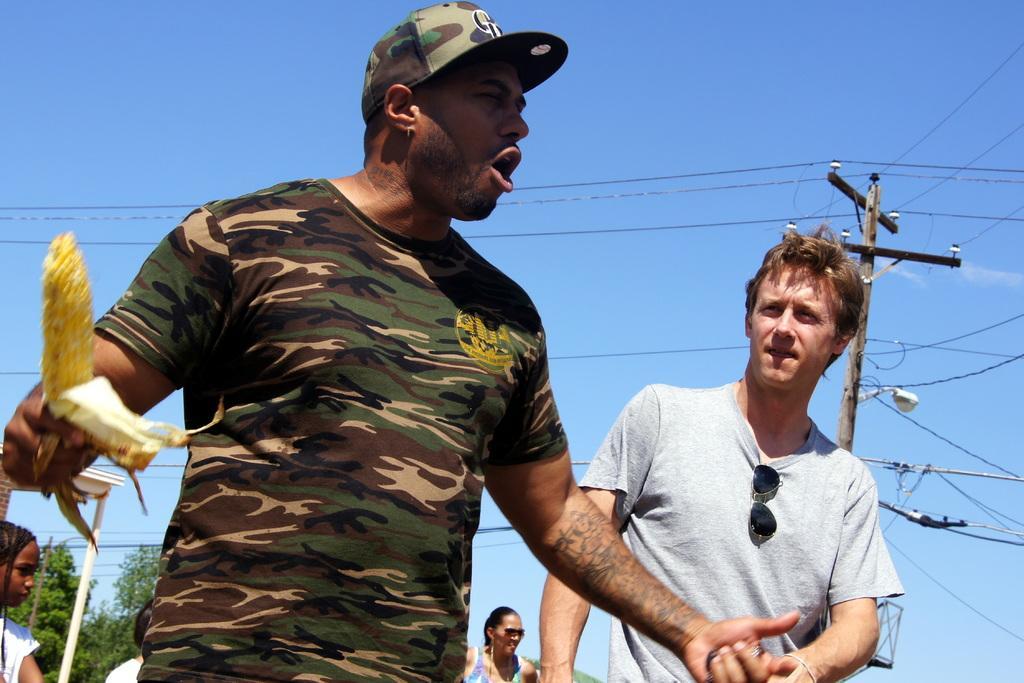Could you give a brief overview of what you see in this image? There are people, among them he is holding a maize. We can see poles, wires and light. In the background we can see trees and sky in blue color. 